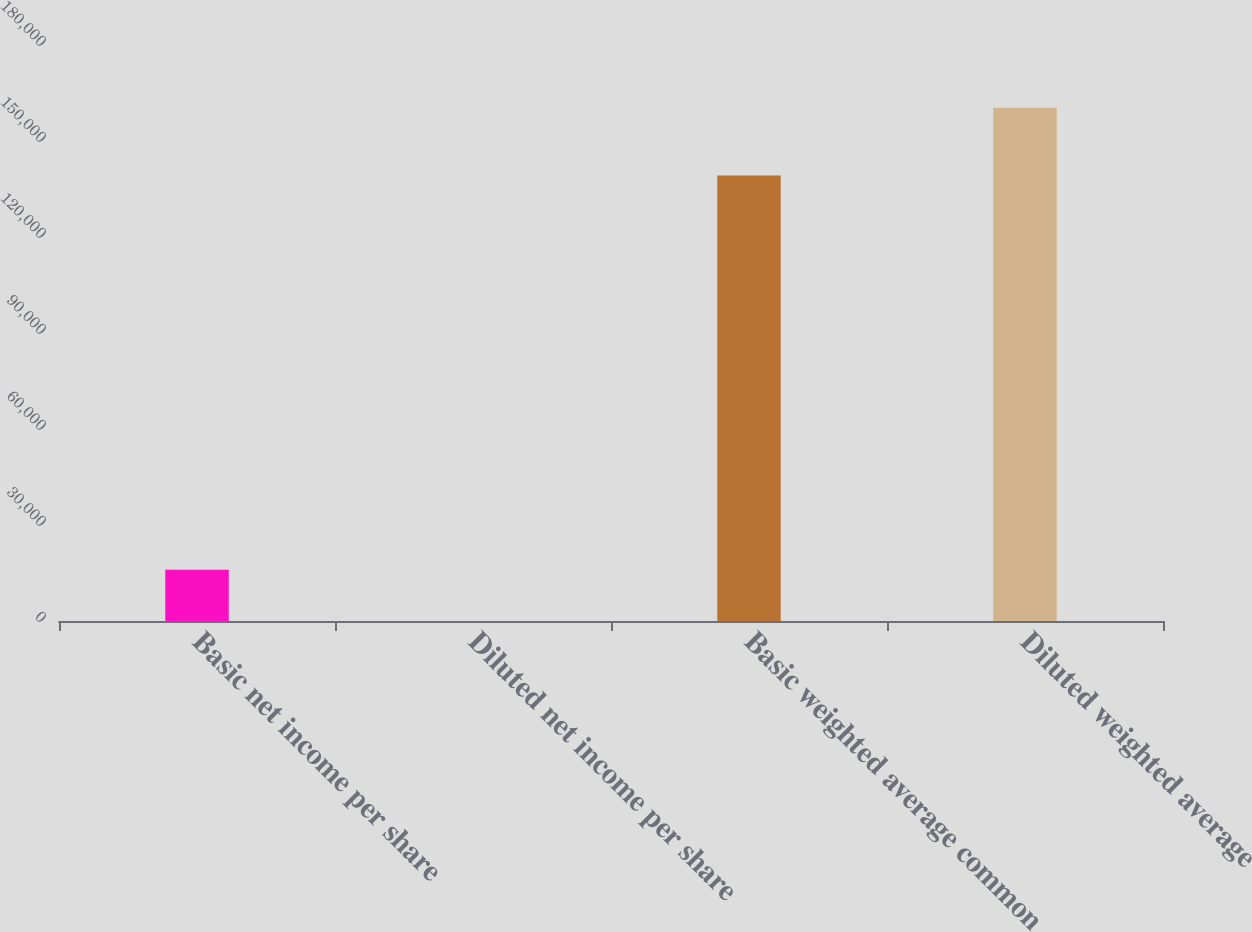Convert chart to OTSL. <chart><loc_0><loc_0><loc_500><loc_500><bar_chart><fcel>Basic net income per share<fcel>Diluted net income per share<fcel>Basic weighted average common<fcel>Diluted weighted average<nl><fcel>16037.7<fcel>1.71<fcel>139204<fcel>160362<nl></chart> 